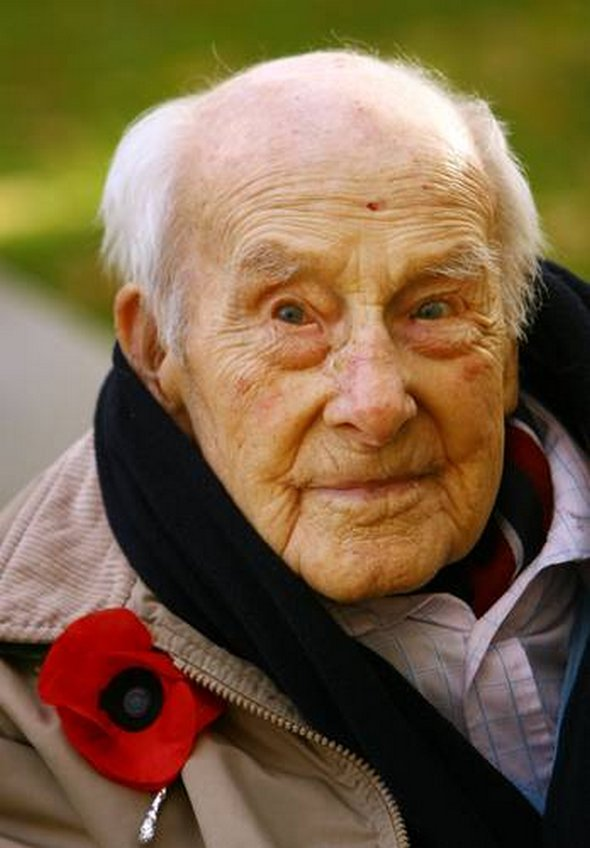What do you notice about the man's expression and what might it signify? The man's expression appears calm and reflective. There is a sense of wisdom and perhaps melancholy in his eyes, which suggest that he is deep in thought. This expression could signify a mixture of emotions such as pride, sorrow, and remembrance. Given the poppy flower, it is likely he is contemplating the sacrifices made during wartime, possibly reminiscing about personal experiences or the loss of comrades. Why might the poppy flower be an important symbol for him? The poppy flower is an enduring symbol of remembrance for those who served and died in the military. It became associated with Remembrance Day following its proliferation on the battlefields of World War I. For the man in the image, wearing the poppy likely holds deep personal significance. It represents not only a tribute to fallen soldiers but also a connection to his own memories and experiences. It is a physical manifestation of respect, honor, and a pledge to never forget the sacrifices made by many during the war. Can you imagine a story where this man is the central character, and create a scene involving him during Remembrance Day? Sure! Imagine a brisk November morning, with leaves gently falling from the trees, creating a golden carpet on the ground. The man, let's call him Henry, stands in front of a war memorial in his small hometown. Dozens of red poppies surround the base of the monument, each one placed by a family member, a friend, or a fellow veteran. Henry, now in his late eighties, adjusts his warm coat and scarf to brace against the cold. As he looks around, he sees faces that have grown older with him, each one carrying their own stories of bravery and loss. Children and grandchildren of veterans hold hands and listen intently as the town mayor gives a heartfelt speech about the importance of remembering their collective history. Henry's mind drifts back to the trenches of Europe, where he was a young soldier, fighting for freedom alongside his best friends. He remembers the laughter, the fear, and the unimaginable loss. A tear rolls down his cheek, not from sadness alone but from the strength of the human spirit that he witnessed during those harrowing times. As the last notes of the bugle call echo through the air, Henry places his poppy on the memorial and salutes, a gesture of deep respect and unwavering commitment to remembering the past. 